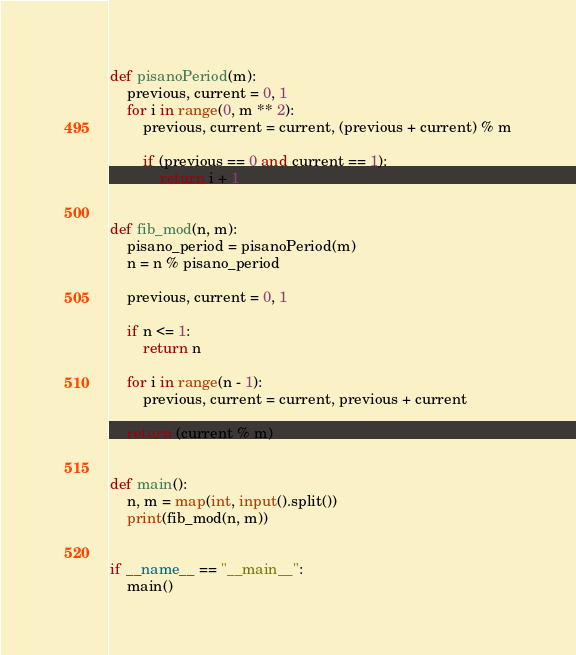Convert code to text. <code><loc_0><loc_0><loc_500><loc_500><_Python_>def pisanoPeriod(m):
    previous, current = 0, 1
    for i in range(0, m ** 2):
        previous, current = current, (previous + current) % m

        if (previous == 0 and current == 1):
            return i + 1


def fib_mod(n, m):
    pisano_period = pisanoPeriod(m)
    n = n % pisano_period

    previous, current = 0, 1

    if n <= 1:
        return n

    for i in range(n - 1):
        previous, current = current, previous + current

    return (current % m)


def main():
    n, m = map(int, input().split())
    print(fib_mod(n, m))


if __name__ == "__main__":
    main()
</code> 